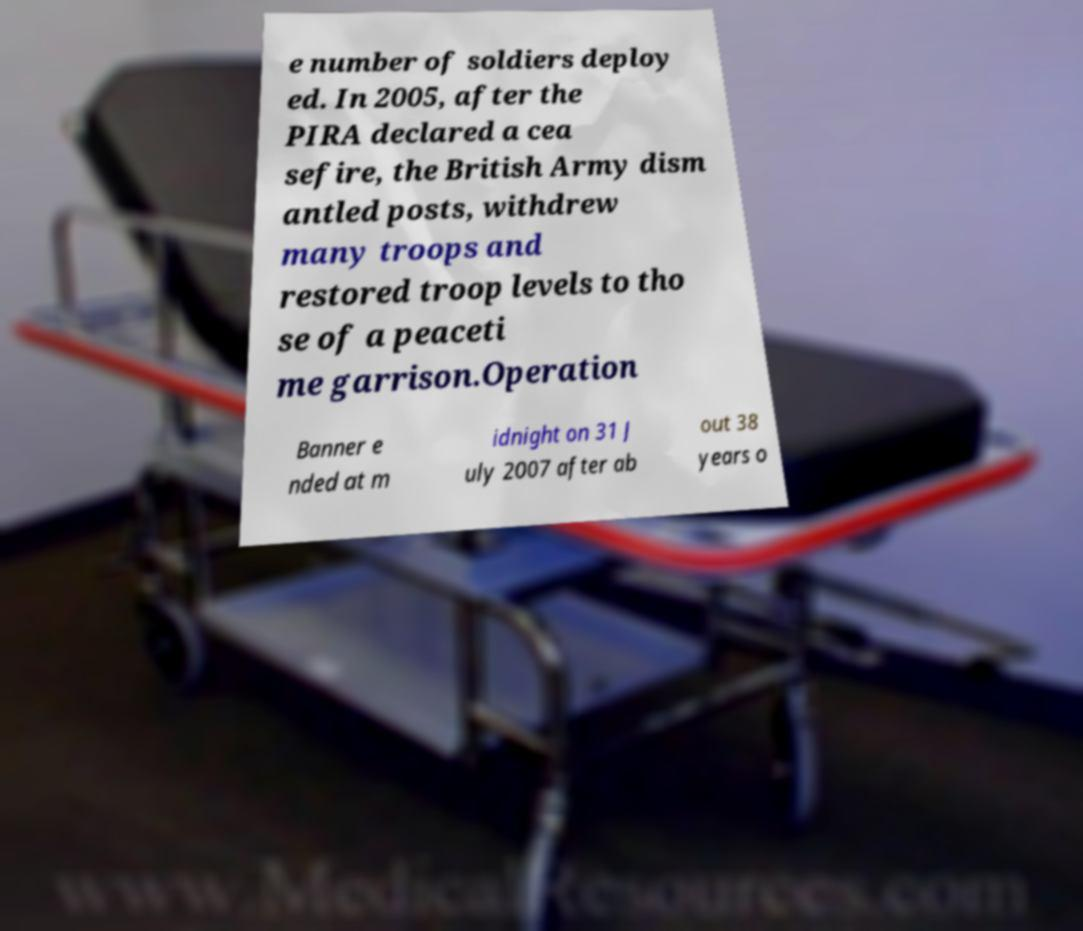What messages or text are displayed in this image? I need them in a readable, typed format. e number of soldiers deploy ed. In 2005, after the PIRA declared a cea sefire, the British Army dism antled posts, withdrew many troops and restored troop levels to tho se of a peaceti me garrison.Operation Banner e nded at m idnight on 31 J uly 2007 after ab out 38 years o 